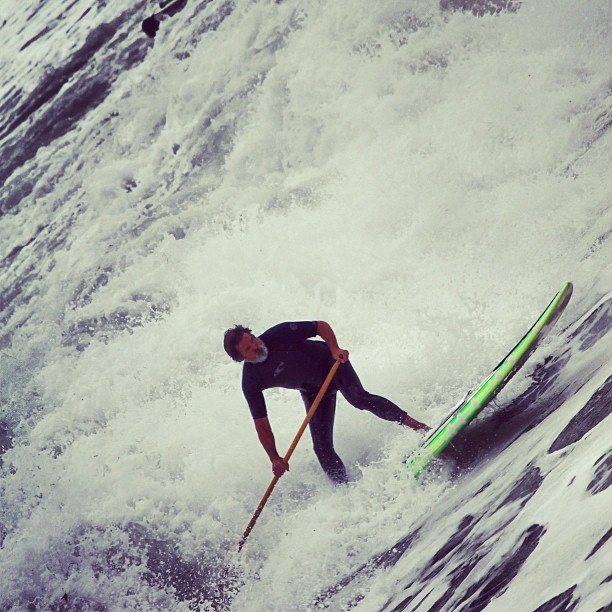Describe the objects in this image and their specific colors. I can see people in beige, navy, lightgray, darkgray, and maroon tones and surfboard in beige, lightgreen, and darkgray tones in this image. 